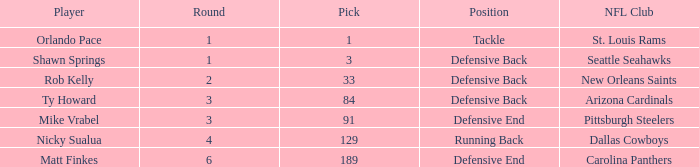What player has defensive back as the position, with a round less than 2? Shawn Springs. 